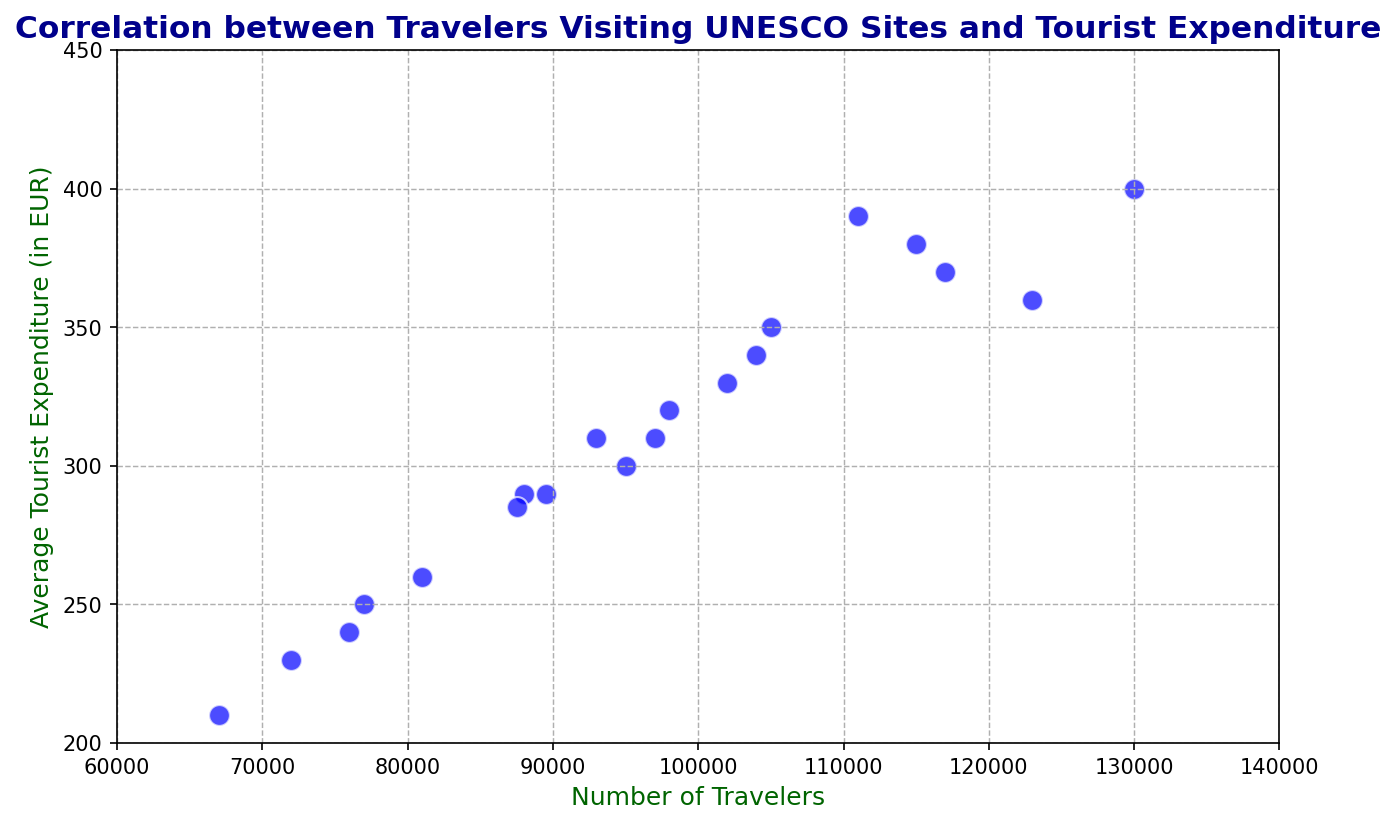What's the range of average tourist expenditures depicted in the figure? To find the range, identify the minimum and maximum values of the average tourist expenditures (y-axis) in the plot. The minimum value is 210 EUR, and the maximum value is 400 EUR. Subtract the minimum value from the maximum value: 400 - 210.
Answer: 190 EUR Between the two data points with the highest and lowest number of travelers, how much does the tourist expenditure difference? Identify the data points with the highest (130,000 travelers) and lowest (67,000 travelers) number of travelers. The corresponding expenditures are 400 EUR and 210 EUR, respectively. Subtract the lower expenditure from the higher expenditure: 400 - 210.
Answer: 190 EUR Does the number of travelers seem to correlate with average tourist expenditure? Assess if there is a notable visual trend in the scatter plot where either an increase or decrease in the number of travelers (x-axis) corresponds with a similar trend in tourist expenditure (y-axis). The points generally trend upwards, meaning higher travelers count typically sees higher expenditures.
Answer: Yes Which data point has the highest average tourist expenditure, and what is its number of travelers? Look at the scatter plot to locate the data point that reaches the highest position on the y-axis. It corresponds to an expenditure of 400 EUR with 130,000 travelers.
Answer: 130,000 travelers How many data points have an average tourist expenditure greater than 350 EUR? Count the number of points on the scatter plot that appear above the 350 EUR mark on the y-axis. These data points are above 350 EUR.
Answer: 4 What is the average tourist expenditure for the data points where the number of travelers is between 90,000 and 100,000? Identify the data points with travelers within the range [90,000, 100,000]. These points have expenditures of 290 EUR, 310 EUR, 320 EUR, 310 EUR, and 285 EUR. Calculate the average: (290 + 310 + 320 + 310 + 285) / 5.
Answer: 303 EUR Are there any data points around 100,000 travelers with a tourist expenditure near 330 EUR? Locate data points near 100,000 travelers (x-axis) and check their corresponding expenditures on the y-axis. A point at 102,000 travelers has an expenditure of 330 EUR.
Answer: Yes 